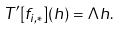Convert formula to latex. <formula><loc_0><loc_0><loc_500><loc_500>T ^ { \prime } [ f _ { i , * } ] ( h ) = \Lambda h .</formula> 